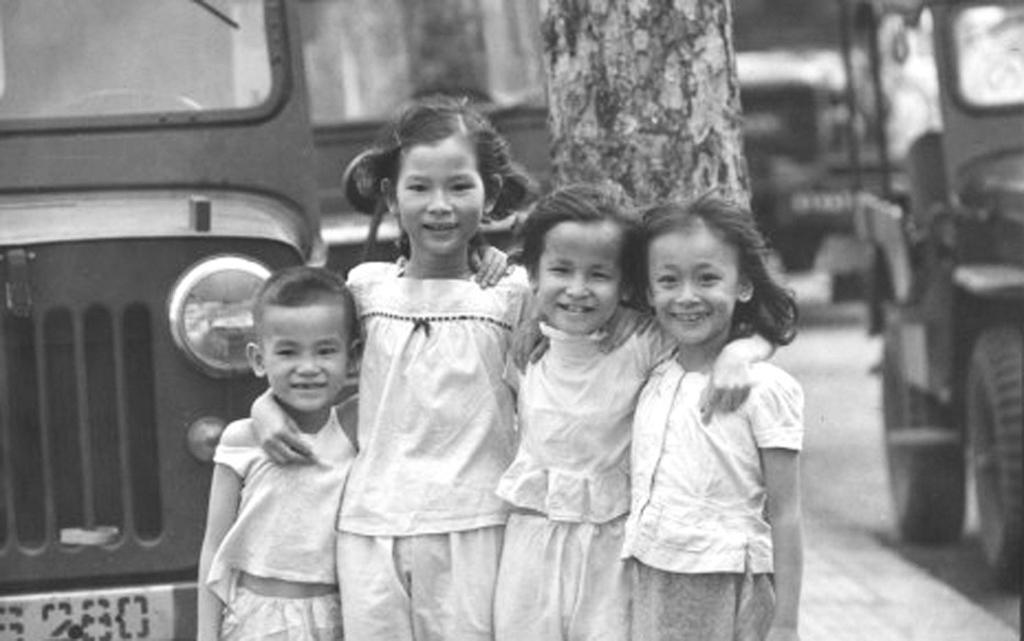How many kids are standing at the front of the image? There are four kids standing at the front of the image. What is located behind the kids? There is a tree trunk behind the kids. What else can be seen in the image besides the kids and tree trunk? Vehicles are visible in the image. What type of spoon is being used by the kids in the image? There is no spoon present in the image. Where is the school located in the image? There is no school present in the image. 